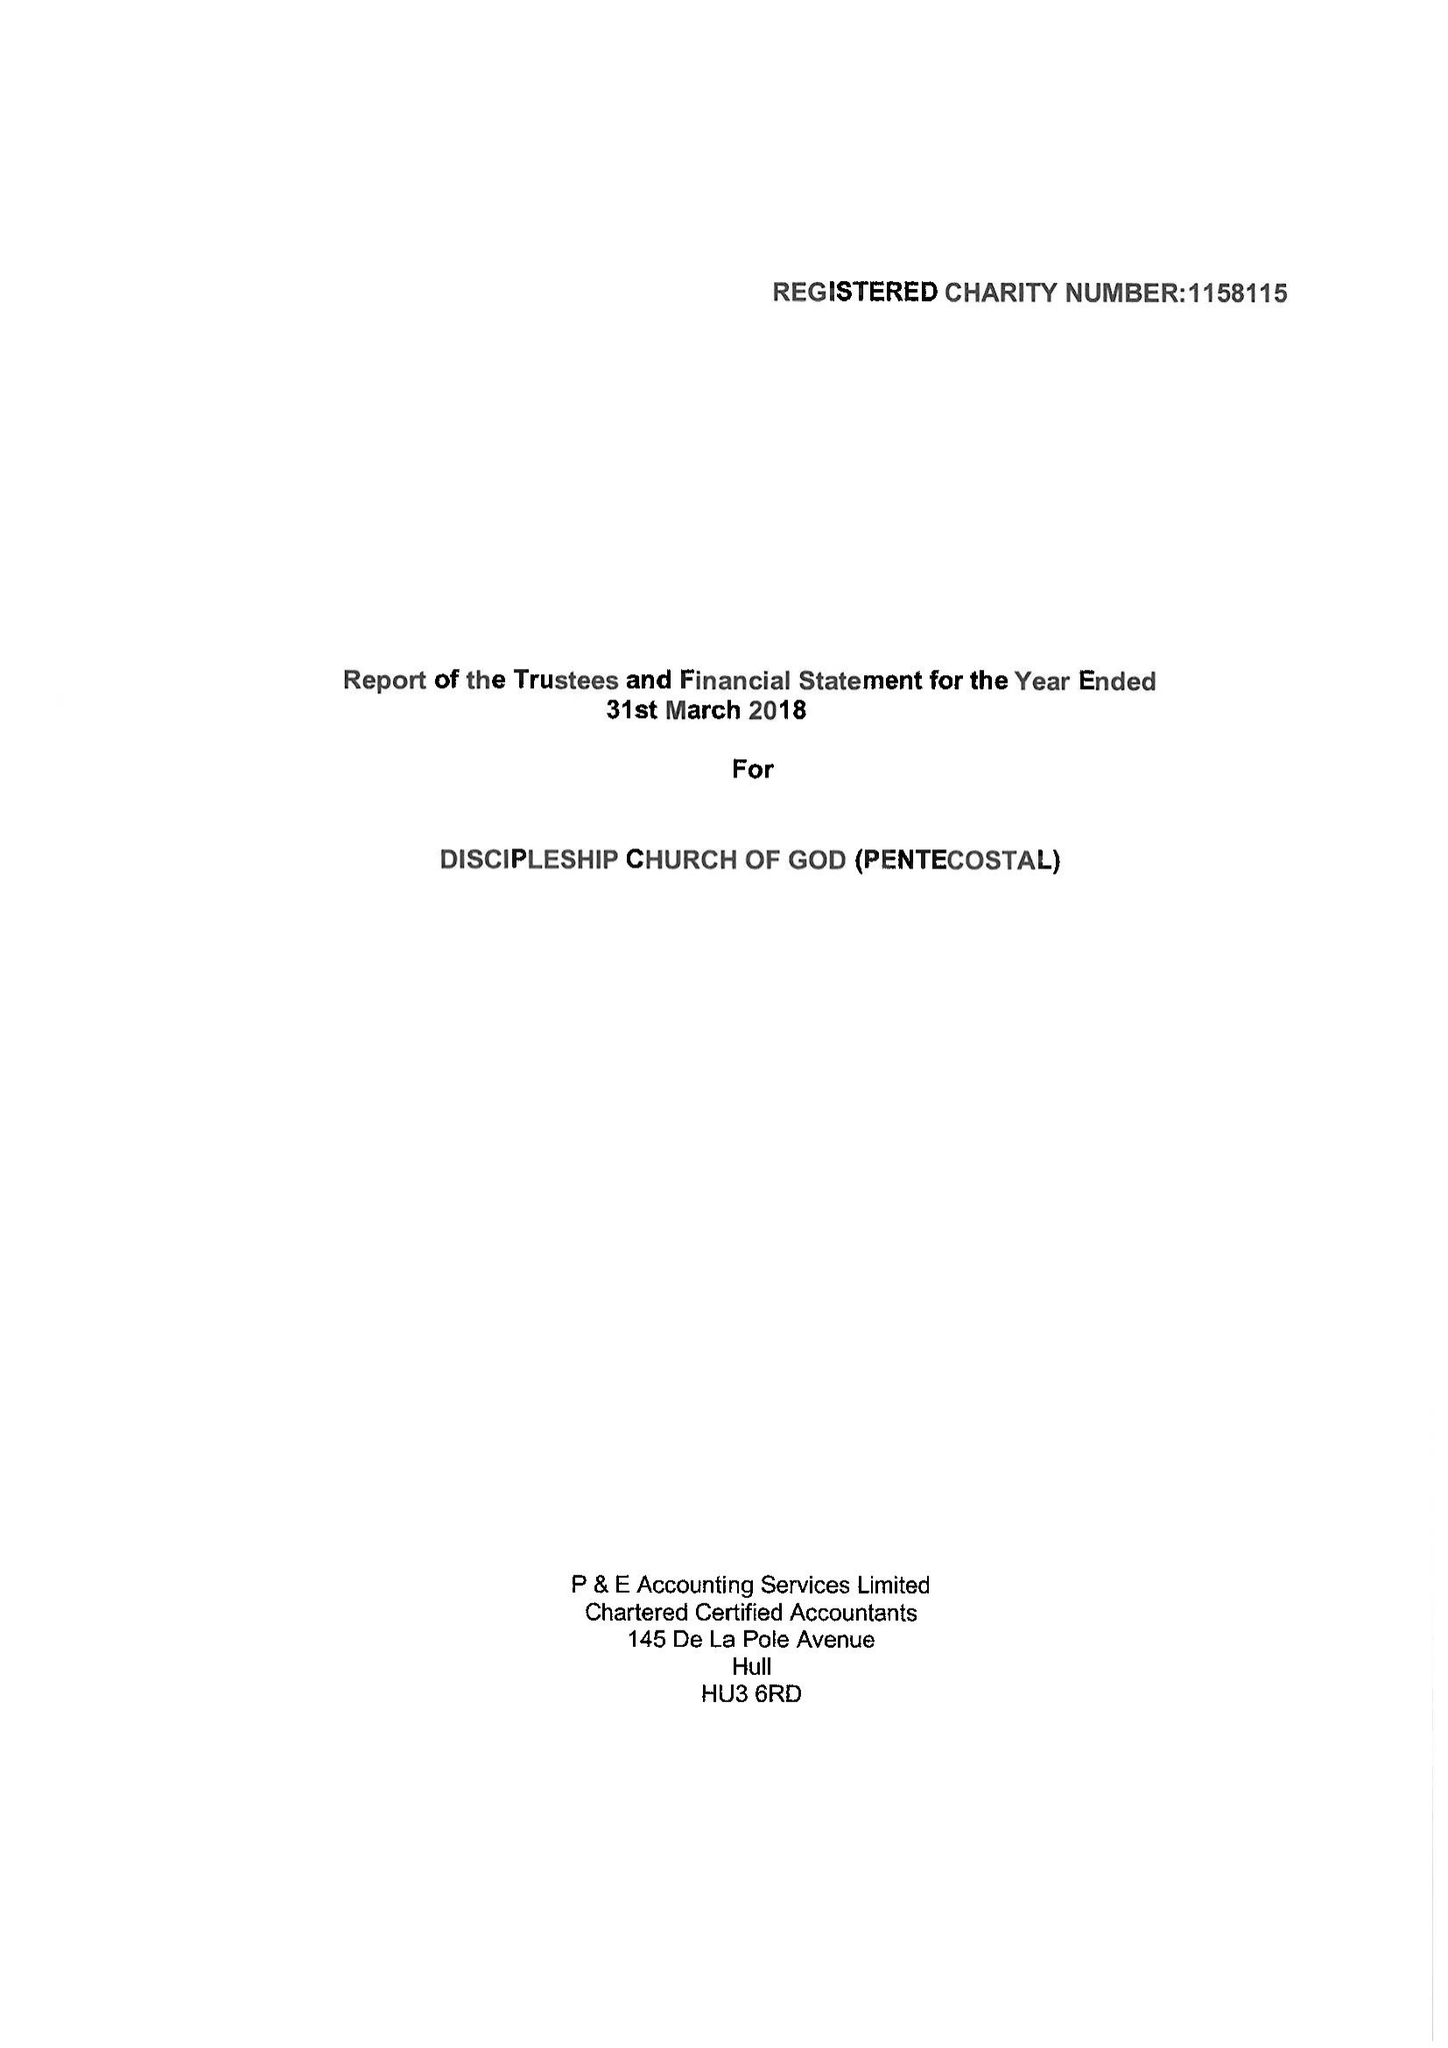What is the value for the address__postcode?
Answer the question using a single word or phrase. SE5 7LE 